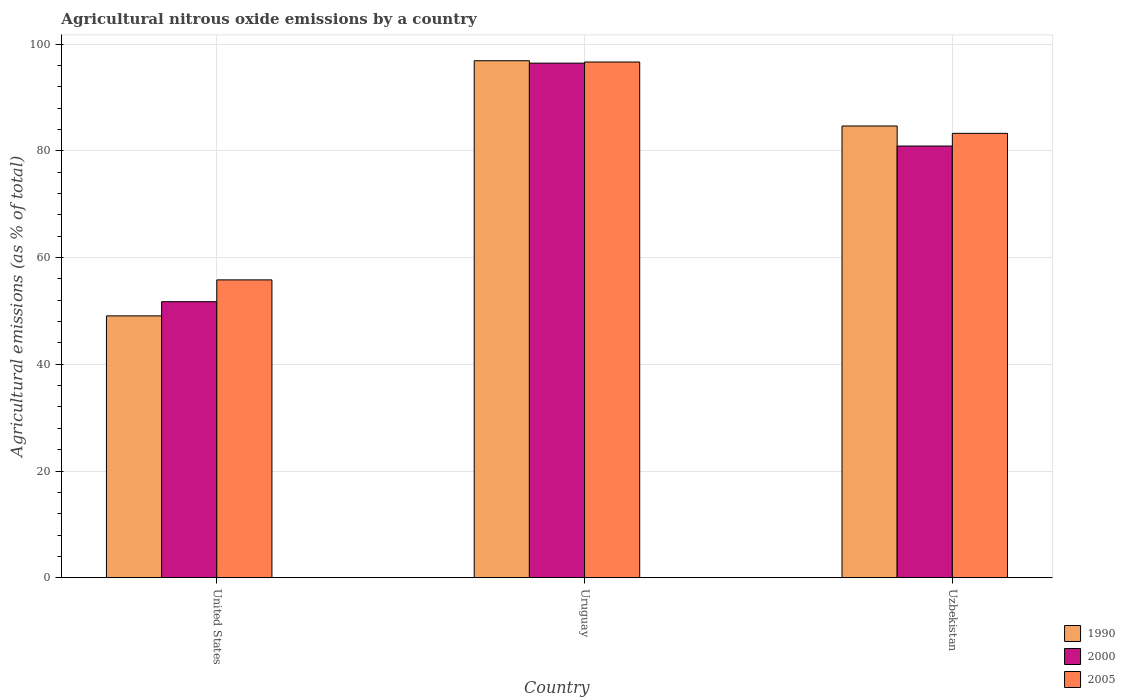How many groups of bars are there?
Make the answer very short. 3. Are the number of bars per tick equal to the number of legend labels?
Offer a terse response. Yes. How many bars are there on the 3rd tick from the right?
Provide a short and direct response. 3. What is the label of the 1st group of bars from the left?
Provide a succinct answer. United States. In how many cases, is the number of bars for a given country not equal to the number of legend labels?
Ensure brevity in your answer.  0. What is the amount of agricultural nitrous oxide emitted in 2000 in Uzbekistan?
Keep it short and to the point. 80.92. Across all countries, what is the maximum amount of agricultural nitrous oxide emitted in 2000?
Your answer should be very brief. 96.45. Across all countries, what is the minimum amount of agricultural nitrous oxide emitted in 1990?
Your response must be concise. 49.08. In which country was the amount of agricultural nitrous oxide emitted in 2000 maximum?
Your answer should be compact. Uruguay. In which country was the amount of agricultural nitrous oxide emitted in 2005 minimum?
Keep it short and to the point. United States. What is the total amount of agricultural nitrous oxide emitted in 1990 in the graph?
Offer a very short reply. 230.66. What is the difference between the amount of agricultural nitrous oxide emitted in 1990 in Uruguay and that in Uzbekistan?
Offer a terse response. 12.23. What is the difference between the amount of agricultural nitrous oxide emitted in 2005 in United States and the amount of agricultural nitrous oxide emitted in 1990 in Uzbekistan?
Offer a very short reply. -28.85. What is the average amount of agricultural nitrous oxide emitted in 2000 per country?
Provide a succinct answer. 76.37. What is the difference between the amount of agricultural nitrous oxide emitted of/in 2000 and amount of agricultural nitrous oxide emitted of/in 2005 in Uzbekistan?
Your answer should be compact. -2.38. In how many countries, is the amount of agricultural nitrous oxide emitted in 2005 greater than 64 %?
Offer a very short reply. 2. What is the ratio of the amount of agricultural nitrous oxide emitted in 1990 in United States to that in Uzbekistan?
Offer a terse response. 0.58. Is the amount of agricultural nitrous oxide emitted in 2000 in Uruguay less than that in Uzbekistan?
Provide a short and direct response. No. What is the difference between the highest and the second highest amount of agricultural nitrous oxide emitted in 2000?
Keep it short and to the point. 44.71. What is the difference between the highest and the lowest amount of agricultural nitrous oxide emitted in 2000?
Provide a short and direct response. 44.71. In how many countries, is the amount of agricultural nitrous oxide emitted in 2005 greater than the average amount of agricultural nitrous oxide emitted in 2005 taken over all countries?
Your answer should be very brief. 2. What does the 1st bar from the left in Uruguay represents?
Provide a short and direct response. 1990. How many bars are there?
Your answer should be very brief. 9. Are all the bars in the graph horizontal?
Give a very brief answer. No. What is the difference between two consecutive major ticks on the Y-axis?
Your answer should be very brief. 20. What is the title of the graph?
Ensure brevity in your answer.  Agricultural nitrous oxide emissions by a country. What is the label or title of the X-axis?
Make the answer very short. Country. What is the label or title of the Y-axis?
Provide a short and direct response. Agricultural emissions (as % of total). What is the Agricultural emissions (as % of total) of 1990 in United States?
Your response must be concise. 49.08. What is the Agricultural emissions (as % of total) of 2000 in United States?
Offer a very short reply. 51.74. What is the Agricultural emissions (as % of total) in 2005 in United States?
Make the answer very short. 55.83. What is the Agricultural emissions (as % of total) in 1990 in Uruguay?
Give a very brief answer. 96.91. What is the Agricultural emissions (as % of total) of 2000 in Uruguay?
Make the answer very short. 96.45. What is the Agricultural emissions (as % of total) of 2005 in Uruguay?
Ensure brevity in your answer.  96.66. What is the Agricultural emissions (as % of total) in 1990 in Uzbekistan?
Provide a succinct answer. 84.67. What is the Agricultural emissions (as % of total) in 2000 in Uzbekistan?
Your response must be concise. 80.92. What is the Agricultural emissions (as % of total) of 2005 in Uzbekistan?
Your answer should be compact. 83.29. Across all countries, what is the maximum Agricultural emissions (as % of total) of 1990?
Make the answer very short. 96.91. Across all countries, what is the maximum Agricultural emissions (as % of total) of 2000?
Your answer should be compact. 96.45. Across all countries, what is the maximum Agricultural emissions (as % of total) of 2005?
Offer a very short reply. 96.66. Across all countries, what is the minimum Agricultural emissions (as % of total) in 1990?
Provide a succinct answer. 49.08. Across all countries, what is the minimum Agricultural emissions (as % of total) in 2000?
Provide a succinct answer. 51.74. Across all countries, what is the minimum Agricultural emissions (as % of total) in 2005?
Your answer should be compact. 55.83. What is the total Agricultural emissions (as % of total) in 1990 in the graph?
Make the answer very short. 230.66. What is the total Agricultural emissions (as % of total) of 2000 in the graph?
Provide a succinct answer. 229.11. What is the total Agricultural emissions (as % of total) of 2005 in the graph?
Your response must be concise. 235.78. What is the difference between the Agricultural emissions (as % of total) of 1990 in United States and that in Uruguay?
Offer a very short reply. -47.83. What is the difference between the Agricultural emissions (as % of total) of 2000 in United States and that in Uruguay?
Provide a succinct answer. -44.71. What is the difference between the Agricultural emissions (as % of total) of 2005 in United States and that in Uruguay?
Offer a very short reply. -40.84. What is the difference between the Agricultural emissions (as % of total) of 1990 in United States and that in Uzbekistan?
Ensure brevity in your answer.  -35.59. What is the difference between the Agricultural emissions (as % of total) in 2000 in United States and that in Uzbekistan?
Keep it short and to the point. -29.18. What is the difference between the Agricultural emissions (as % of total) in 2005 in United States and that in Uzbekistan?
Your response must be concise. -27.47. What is the difference between the Agricultural emissions (as % of total) in 1990 in Uruguay and that in Uzbekistan?
Make the answer very short. 12.23. What is the difference between the Agricultural emissions (as % of total) in 2000 in Uruguay and that in Uzbekistan?
Provide a succinct answer. 15.53. What is the difference between the Agricultural emissions (as % of total) of 2005 in Uruguay and that in Uzbekistan?
Offer a terse response. 13.37. What is the difference between the Agricultural emissions (as % of total) of 1990 in United States and the Agricultural emissions (as % of total) of 2000 in Uruguay?
Keep it short and to the point. -47.37. What is the difference between the Agricultural emissions (as % of total) of 1990 in United States and the Agricultural emissions (as % of total) of 2005 in Uruguay?
Make the answer very short. -47.58. What is the difference between the Agricultural emissions (as % of total) in 2000 in United States and the Agricultural emissions (as % of total) in 2005 in Uruguay?
Your answer should be very brief. -44.93. What is the difference between the Agricultural emissions (as % of total) in 1990 in United States and the Agricultural emissions (as % of total) in 2000 in Uzbekistan?
Provide a short and direct response. -31.84. What is the difference between the Agricultural emissions (as % of total) in 1990 in United States and the Agricultural emissions (as % of total) in 2005 in Uzbekistan?
Offer a terse response. -34.21. What is the difference between the Agricultural emissions (as % of total) in 2000 in United States and the Agricultural emissions (as % of total) in 2005 in Uzbekistan?
Provide a short and direct response. -31.56. What is the difference between the Agricultural emissions (as % of total) of 1990 in Uruguay and the Agricultural emissions (as % of total) of 2000 in Uzbekistan?
Your answer should be very brief. 15.99. What is the difference between the Agricultural emissions (as % of total) in 1990 in Uruguay and the Agricultural emissions (as % of total) in 2005 in Uzbekistan?
Ensure brevity in your answer.  13.61. What is the difference between the Agricultural emissions (as % of total) of 2000 in Uruguay and the Agricultural emissions (as % of total) of 2005 in Uzbekistan?
Your answer should be very brief. 13.16. What is the average Agricultural emissions (as % of total) in 1990 per country?
Offer a terse response. 76.89. What is the average Agricultural emissions (as % of total) of 2000 per country?
Provide a succinct answer. 76.37. What is the average Agricultural emissions (as % of total) in 2005 per country?
Make the answer very short. 78.59. What is the difference between the Agricultural emissions (as % of total) of 1990 and Agricultural emissions (as % of total) of 2000 in United States?
Make the answer very short. -2.66. What is the difference between the Agricultural emissions (as % of total) of 1990 and Agricultural emissions (as % of total) of 2005 in United States?
Provide a short and direct response. -6.75. What is the difference between the Agricultural emissions (as % of total) in 2000 and Agricultural emissions (as % of total) in 2005 in United States?
Provide a short and direct response. -4.09. What is the difference between the Agricultural emissions (as % of total) in 1990 and Agricultural emissions (as % of total) in 2000 in Uruguay?
Give a very brief answer. 0.46. What is the difference between the Agricultural emissions (as % of total) in 1990 and Agricultural emissions (as % of total) in 2005 in Uruguay?
Offer a terse response. 0.24. What is the difference between the Agricultural emissions (as % of total) of 2000 and Agricultural emissions (as % of total) of 2005 in Uruguay?
Keep it short and to the point. -0.21. What is the difference between the Agricultural emissions (as % of total) in 1990 and Agricultural emissions (as % of total) in 2000 in Uzbekistan?
Give a very brief answer. 3.76. What is the difference between the Agricultural emissions (as % of total) of 1990 and Agricultural emissions (as % of total) of 2005 in Uzbekistan?
Keep it short and to the point. 1.38. What is the difference between the Agricultural emissions (as % of total) in 2000 and Agricultural emissions (as % of total) in 2005 in Uzbekistan?
Provide a succinct answer. -2.38. What is the ratio of the Agricultural emissions (as % of total) in 1990 in United States to that in Uruguay?
Your answer should be compact. 0.51. What is the ratio of the Agricultural emissions (as % of total) of 2000 in United States to that in Uruguay?
Provide a short and direct response. 0.54. What is the ratio of the Agricultural emissions (as % of total) in 2005 in United States to that in Uruguay?
Your answer should be compact. 0.58. What is the ratio of the Agricultural emissions (as % of total) of 1990 in United States to that in Uzbekistan?
Provide a succinct answer. 0.58. What is the ratio of the Agricultural emissions (as % of total) in 2000 in United States to that in Uzbekistan?
Give a very brief answer. 0.64. What is the ratio of the Agricultural emissions (as % of total) of 2005 in United States to that in Uzbekistan?
Provide a succinct answer. 0.67. What is the ratio of the Agricultural emissions (as % of total) of 1990 in Uruguay to that in Uzbekistan?
Give a very brief answer. 1.14. What is the ratio of the Agricultural emissions (as % of total) in 2000 in Uruguay to that in Uzbekistan?
Make the answer very short. 1.19. What is the ratio of the Agricultural emissions (as % of total) in 2005 in Uruguay to that in Uzbekistan?
Keep it short and to the point. 1.16. What is the difference between the highest and the second highest Agricultural emissions (as % of total) of 1990?
Your response must be concise. 12.23. What is the difference between the highest and the second highest Agricultural emissions (as % of total) in 2000?
Ensure brevity in your answer.  15.53. What is the difference between the highest and the second highest Agricultural emissions (as % of total) in 2005?
Your response must be concise. 13.37. What is the difference between the highest and the lowest Agricultural emissions (as % of total) of 1990?
Provide a succinct answer. 47.83. What is the difference between the highest and the lowest Agricultural emissions (as % of total) of 2000?
Your response must be concise. 44.71. What is the difference between the highest and the lowest Agricultural emissions (as % of total) in 2005?
Your response must be concise. 40.84. 